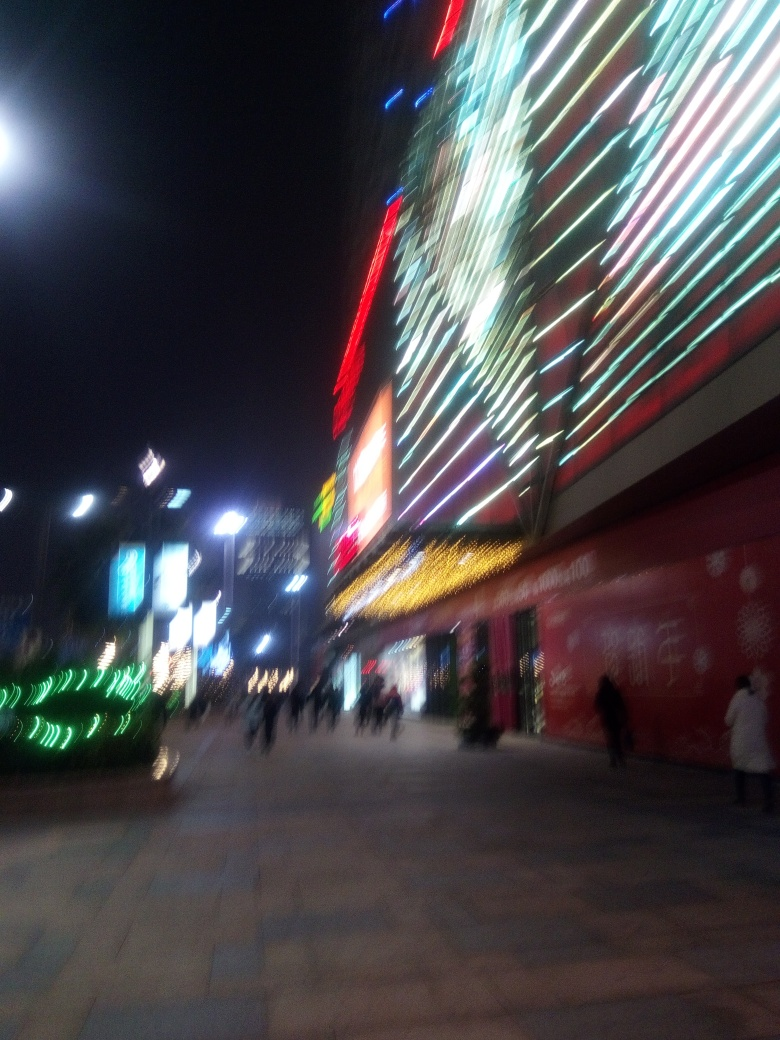What time of day does this image seem to capture, and how can you tell? This image appears to capture a nighttime scene, which is evident from the artificial lighting prominently displayed on the buildings and the darkness in the sky, suggesting that it's after sunset. 